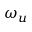<formula> <loc_0><loc_0><loc_500><loc_500>\omega _ { u }</formula> 